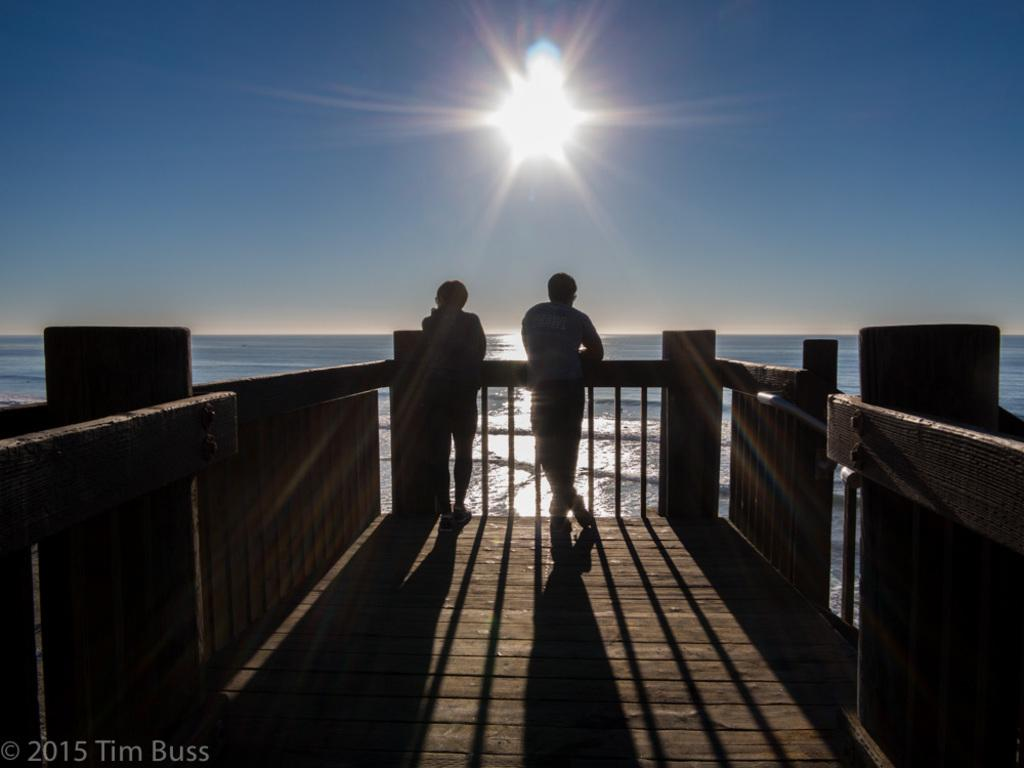How many people are in the image? There are two persons in the image. What are the two persons doing in the image? The two persons are standing and leaning on a wooden fence. What is in front of the two persons? There is a river in front of the two persons. What can be seen in the background of the image? The sky is visible in the background of the image. What type of worm can be seen crawling on the wooden fence in the image? There is no worm present in the image; the two persons are standing and leaning on the wooden fence. Is there a jail visible in the image? No, there is no jail present in the image. 